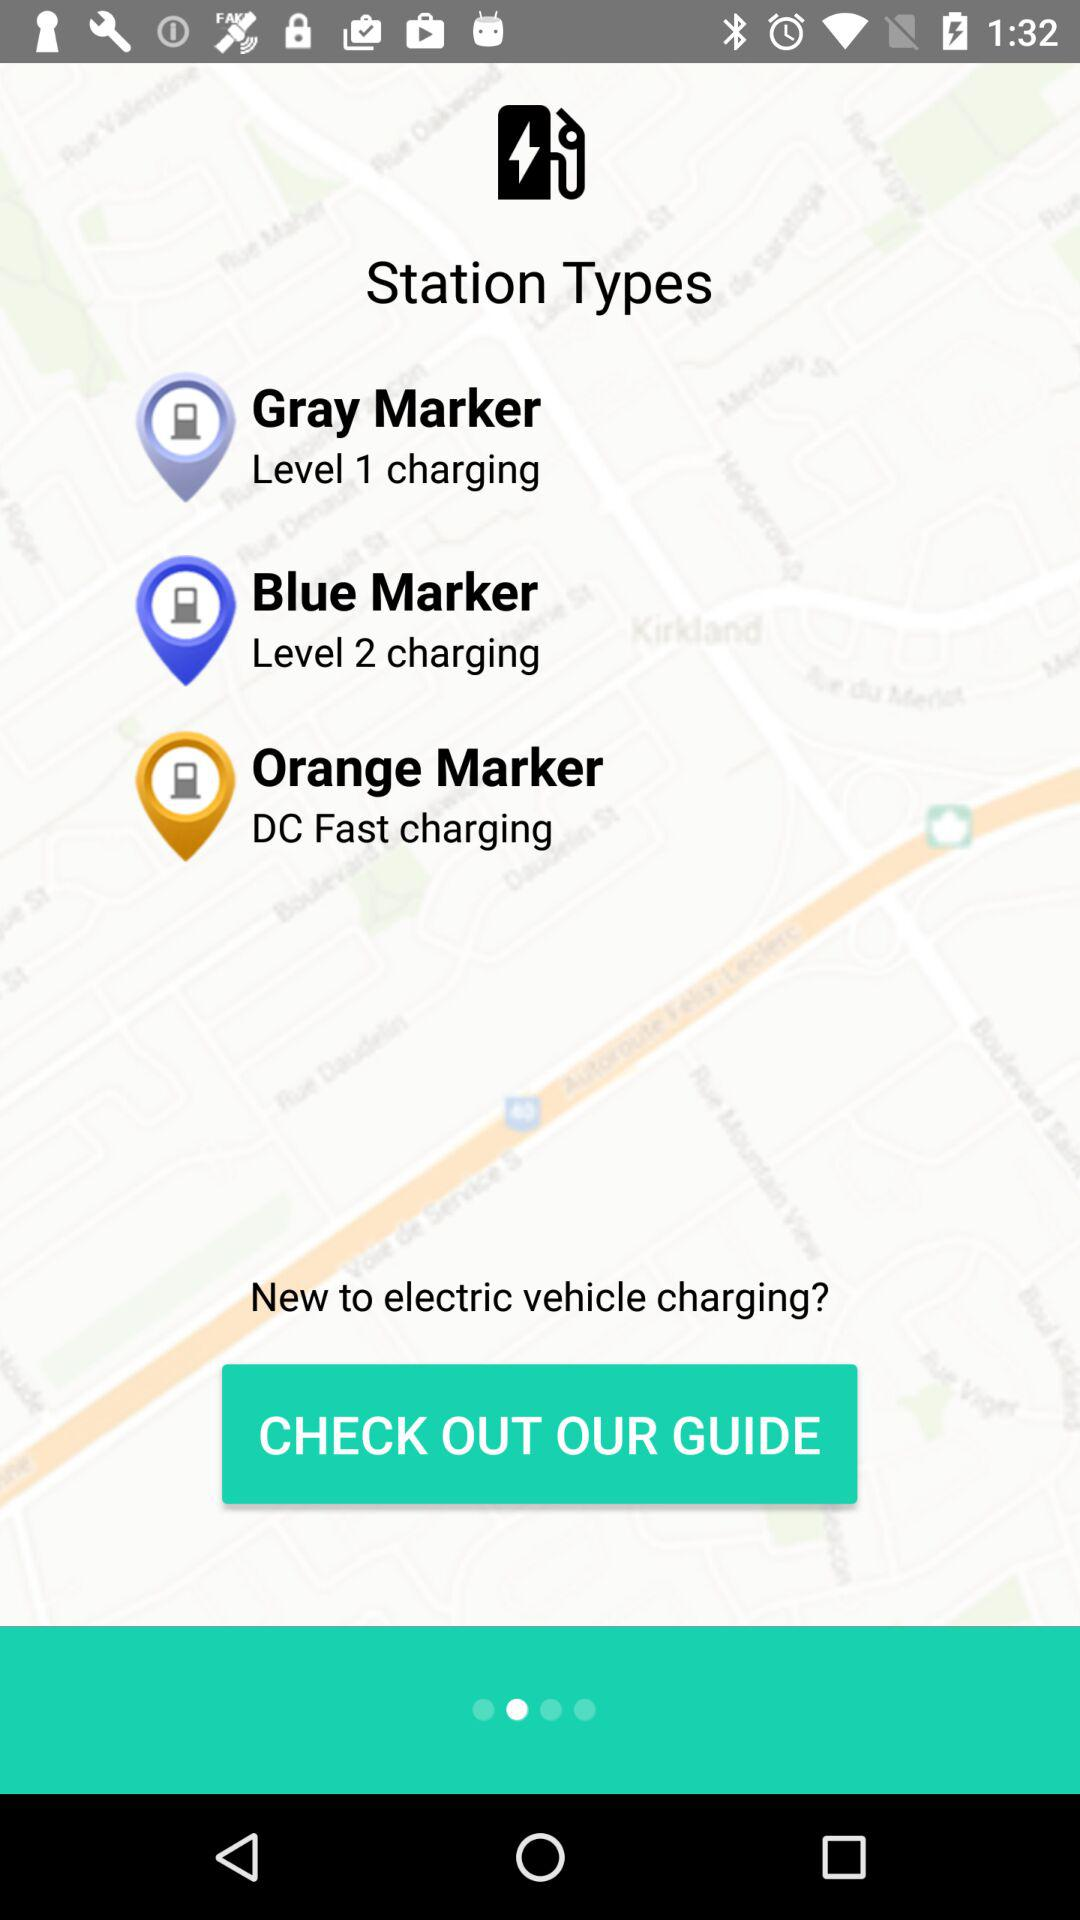What type of charging station does the orange marker represent? The orange marker represents a "DC Fast charging" type of charging station. 